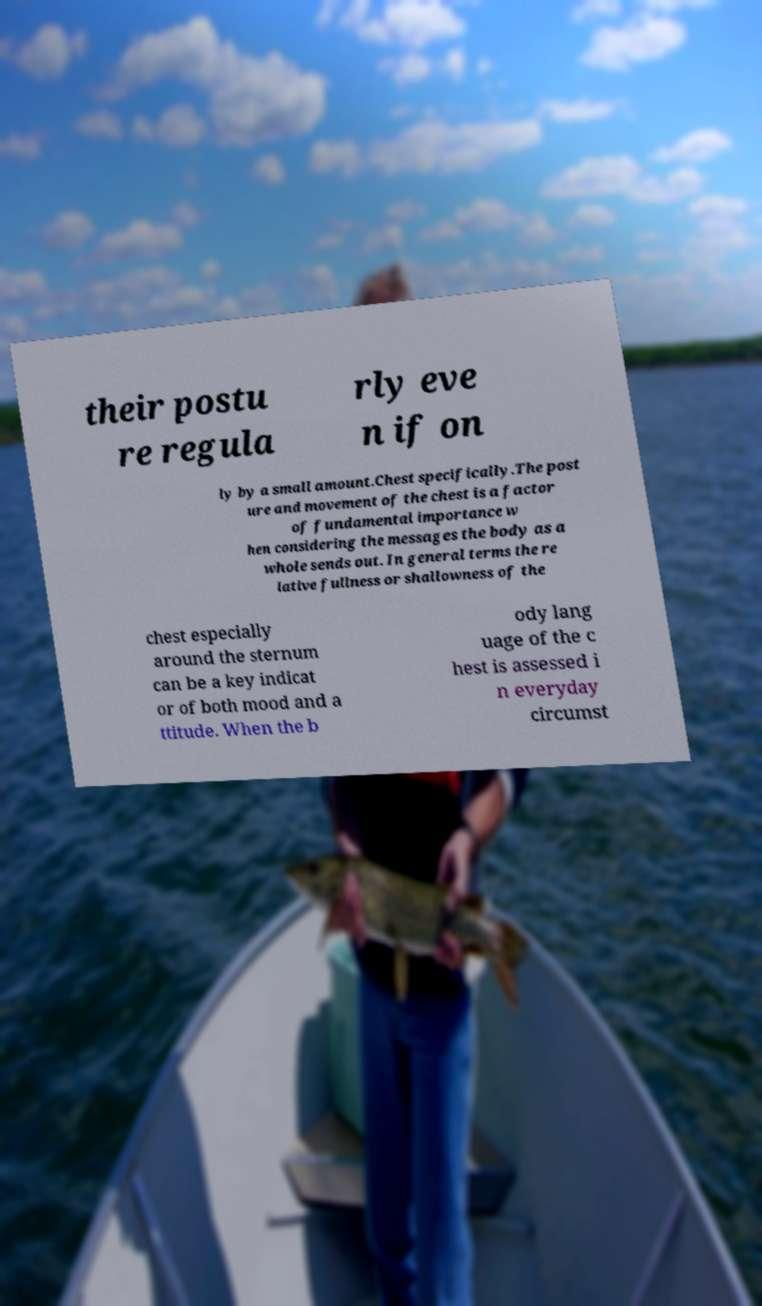Could you assist in decoding the text presented in this image and type it out clearly? their postu re regula rly eve n if on ly by a small amount.Chest specifically.The post ure and movement of the chest is a factor of fundamental importance w hen considering the messages the body as a whole sends out. In general terms the re lative fullness or shallowness of the chest especially around the sternum can be a key indicat or of both mood and a ttitude. When the b ody lang uage of the c hest is assessed i n everyday circumst 